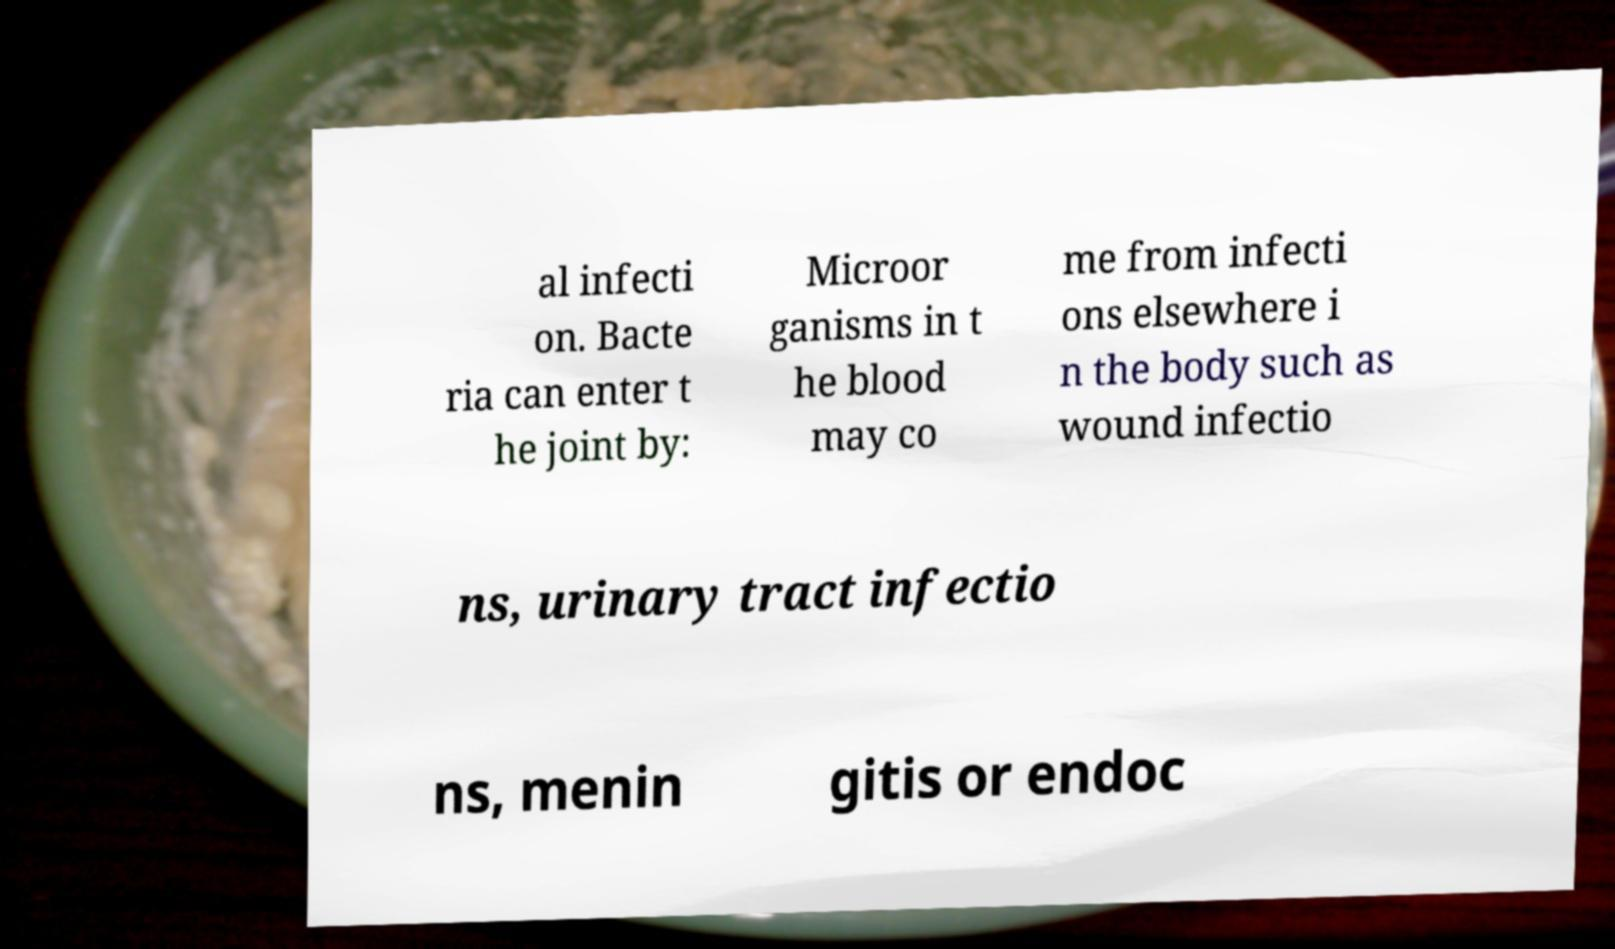Can you accurately transcribe the text from the provided image for me? al infecti on. Bacte ria can enter t he joint by: Microor ganisms in t he blood may co me from infecti ons elsewhere i n the body such as wound infectio ns, urinary tract infectio ns, menin gitis or endoc 